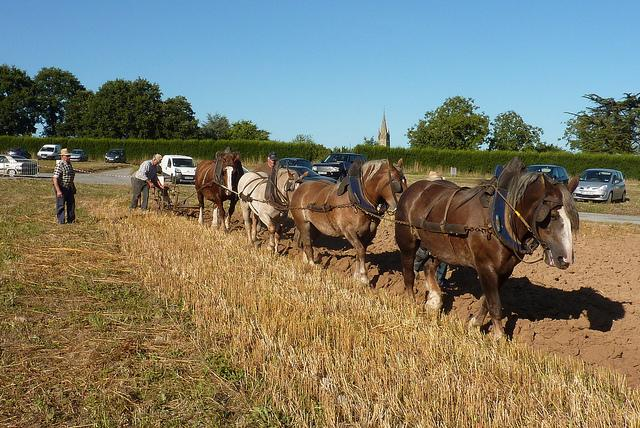Why are horses eyes covered? Please explain your reasoning. insects. The eye patches keep away distracting flies. 